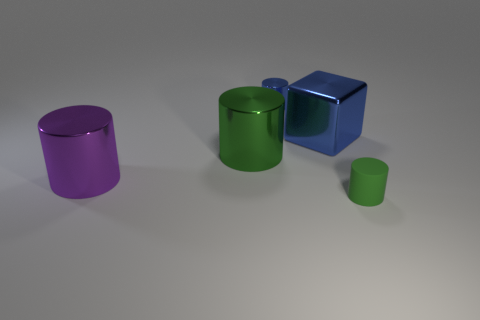Add 1 large blue cubes. How many objects exist? 6 Subtract all cylinders. How many objects are left? 1 Subtract 0 cyan spheres. How many objects are left? 5 Subtract all green shiny cylinders. Subtract all blue metal things. How many objects are left? 2 Add 1 blue blocks. How many blue blocks are left? 2 Add 5 blue metal cylinders. How many blue metal cylinders exist? 6 